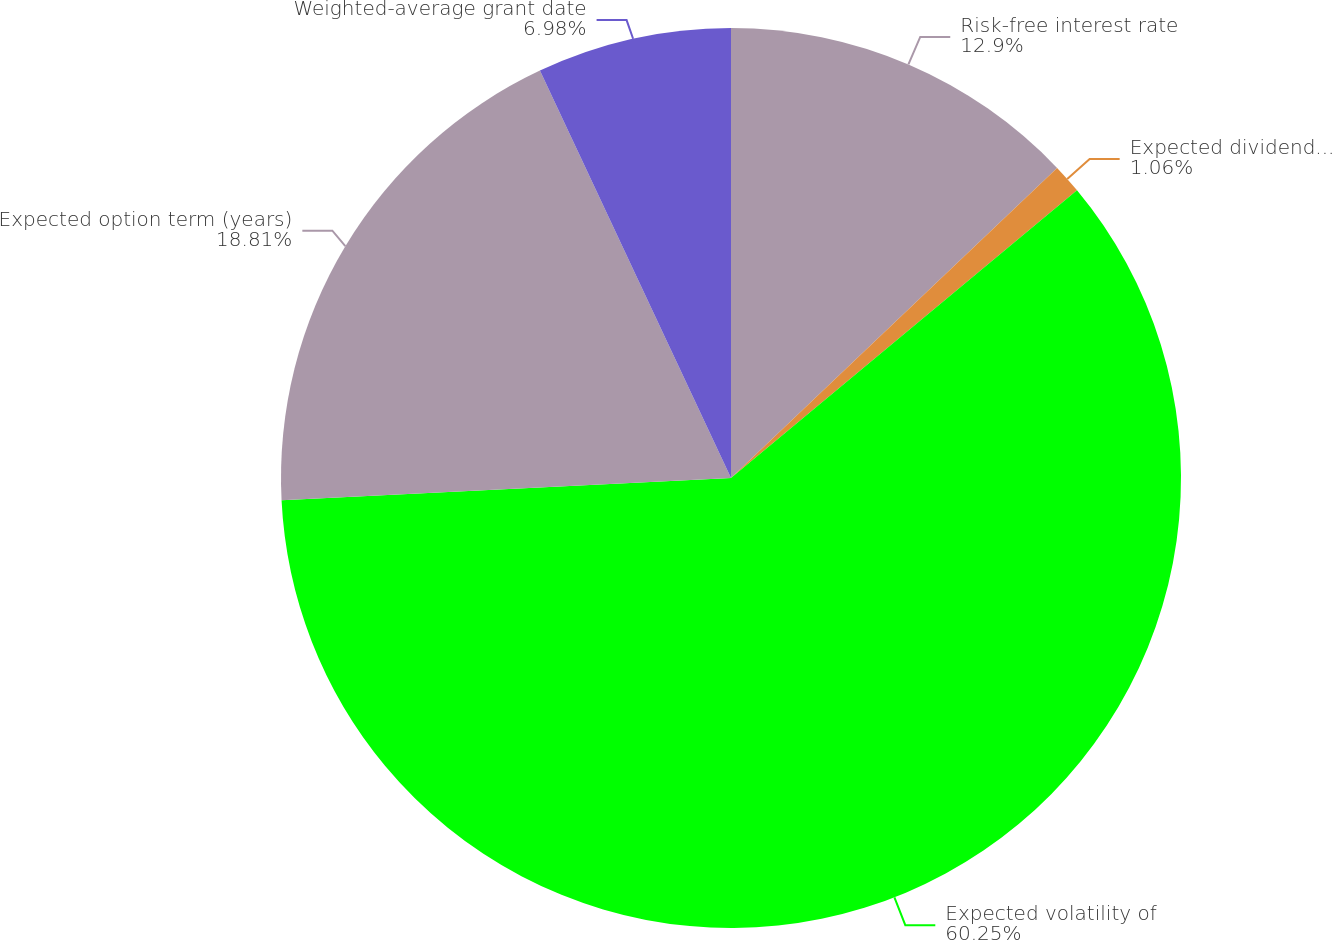Convert chart to OTSL. <chart><loc_0><loc_0><loc_500><loc_500><pie_chart><fcel>Risk-free interest rate<fcel>Expected dividend yield<fcel>Expected volatility of<fcel>Expected option term (years)<fcel>Weighted-average grant date<nl><fcel>12.9%<fcel>1.06%<fcel>60.25%<fcel>18.81%<fcel>6.98%<nl></chart> 